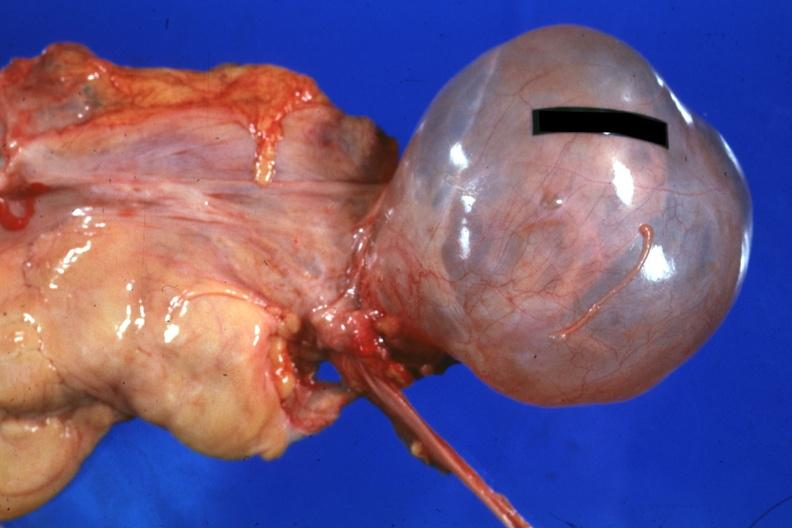s serous cyst present?
Answer the question using a single word or phrase. Yes 